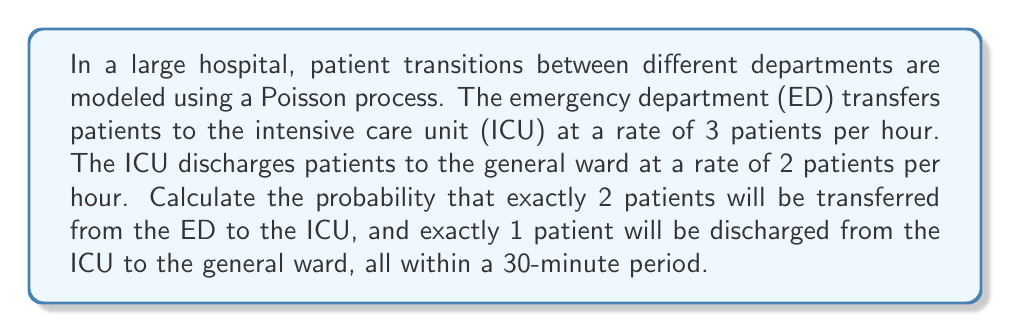Solve this math problem. To solve this problem, we need to use the properties of Poisson processes and calculate the probabilities for each event independently, then multiply them together.

1. For the ED to ICU transfers:
   - Rate (λ₁) = 3 patients/hour
   - Time interval (t) = 0.5 hours (30 minutes)
   - Number of events (k₁) = 2 patients

   The probability is given by the Poisson distribution formula:
   $$P(X = k) = \frac{e^{-λt}(λt)^k}{k!}$$

   $$P(X = 2) = \frac{e^{-(3 * 0.5)}((3 * 0.5)^2)}{2!}$$
   $$= \frac{e^{-1.5} * 2.25}{2}$$

2. For the ICU to general ward discharges:
   - Rate (λ₂) = 2 patients/hour
   - Time interval (t) = 0.5 hours (30 minutes)
   - Number of events (k₂) = 1 patient

   Using the same Poisson distribution formula:

   $$P(Y = 1) = \frac{e^{-(2 * 0.5)}((2 * 0.5)^1)}{1!}$$
   $$= e^{-1} * 1$$

3. The probability of both events occurring independently is the product of their individual probabilities:

   $$P(\text{2 ED to ICU and 1 ICU to ward}) = P(X = 2) * P(Y = 1)$$
   $$= \frac{e^{-1.5} * 2.25}{2} * e^{-1} * 1$$
   $$= \frac{e^{-2.5} * 2.25}{2}$$
   $$≈ 0.0620$$
Answer: $\frac{e^{-2.5} * 2.25}{2} ≈ 0.0620$ 